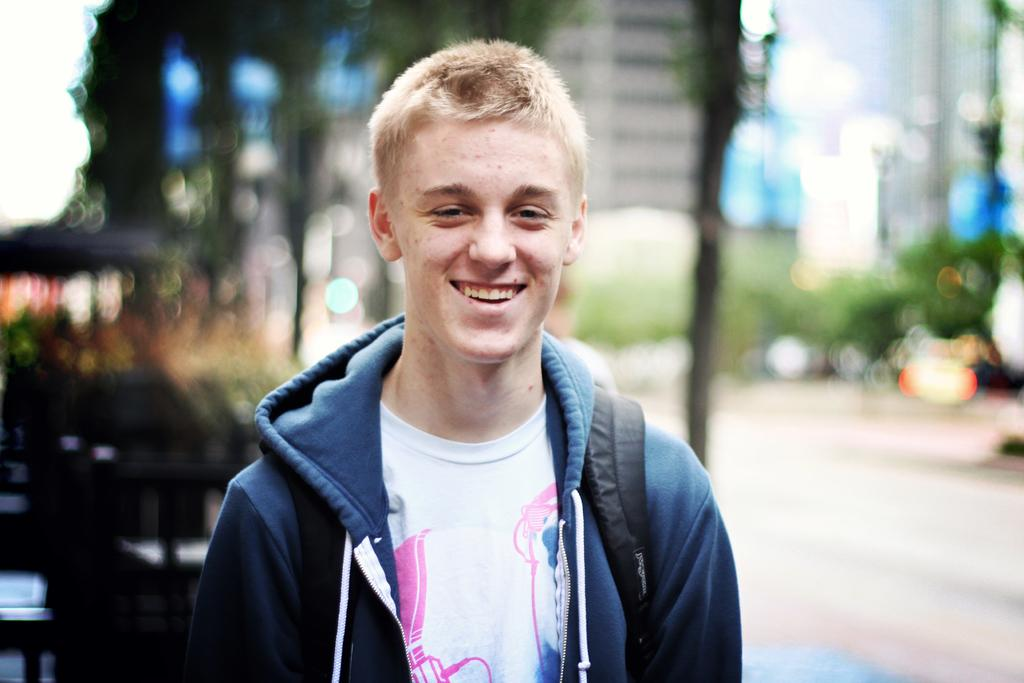Who is present in the image? There is a man in the image. What is the man's facial expression? The man is smiling. What type of clothing is the man wearing on top? The man is wearing a sweater. What type of clothing is the man wearing underneath the sweater? The man is wearing a white t-shirt. How many ants are crawling on the man's sweater in the image? There are no ants present in the image. What type of ink is the man using to write on the t-shirt in the image? There is no ink or writing on the man's t-shirt in the image. 